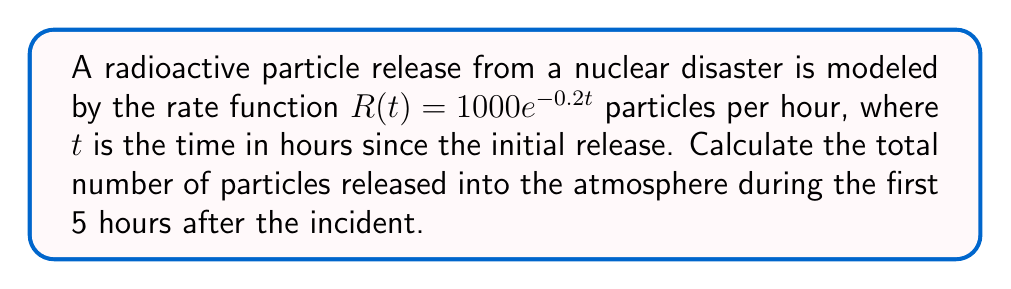Help me with this question. To find the total number of particles released over a period of time, we need to integrate the rate function over that time interval. Here's how we can solve this problem step-by-step:

1) The rate function is given as $R(t) = 1000e^{-0.2t}$ particles/hour.

2) We need to find the definite integral of this function from $t=0$ to $t=5$:

   $$\int_0^5 1000e^{-0.2t} dt$$

3) To integrate, we can use the rule for exponential functions: $\int e^{ax} dx = \frac{1}{a}e^{ax} + C$

4) Applying this rule to our integral:

   $$\left[-5000e^{-0.2t}\right]_0^5$$

5) Now we evaluate this at the limits:

   $$-5000e^{-0.2(5)} - (-5000e^{-0.2(0)})$$

6) Simplify:

   $$-5000e^{-1} - (-5000)$$

7) Calculate:

   $$-5000(0.3679) + 5000 = -1839.5 + 5000 = 3160.5$$

Therefore, approximately 3160.5 particles were released during the first 5 hours.
Answer: 3160.5 particles 